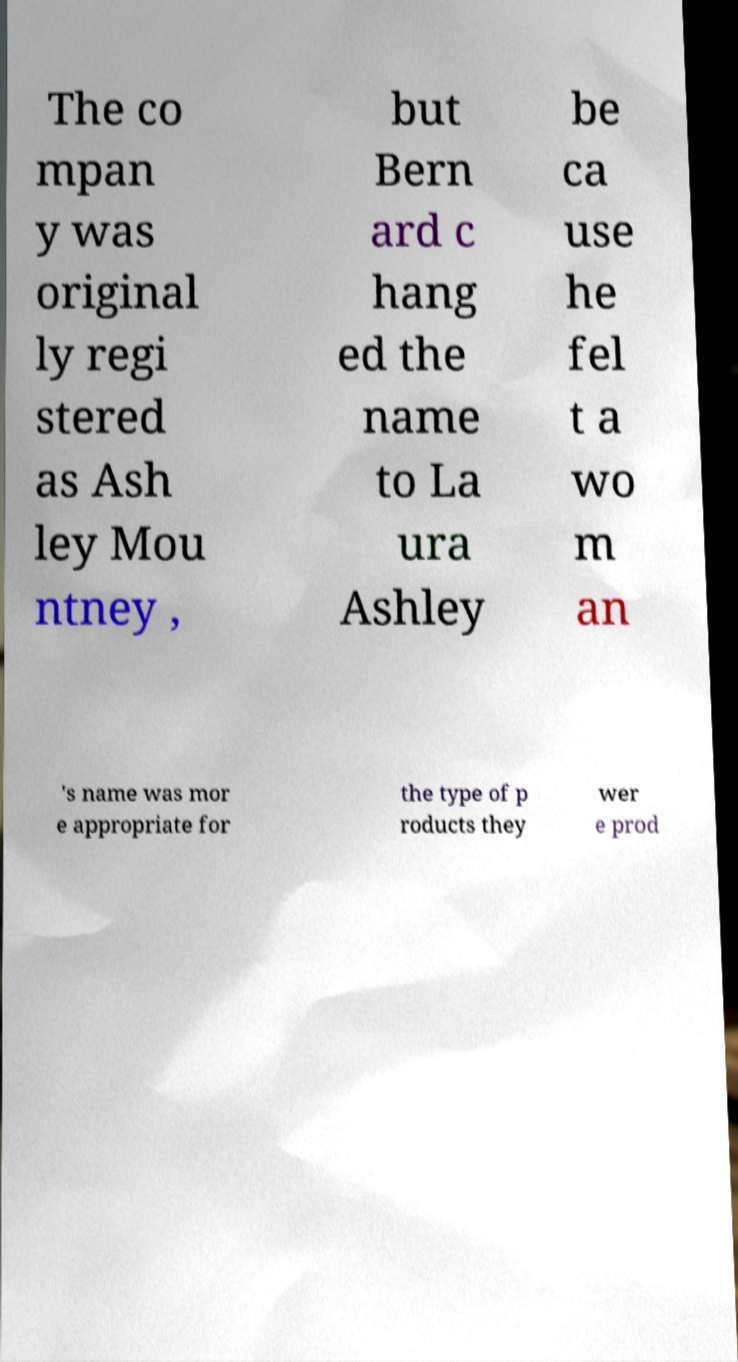What kind of products did Laura Ashley originally produce? Laura Ashley initially gained fame for its distinctive floral fabrics, which were originally printed on a small scale at the Ashley's home. The company expanded its range over time to include a wide variety of home furnishings and clothing, all styled with the quaint, pastoral, and classic design aesthetics that became synonymous with the Laura Ashley brand. 